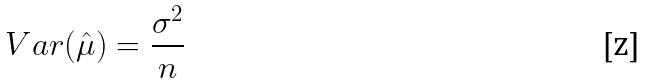Convert formula to latex. <formula><loc_0><loc_0><loc_500><loc_500>V a r ( \hat { \mu } ) = \frac { \sigma ^ { 2 } } { n }</formula> 